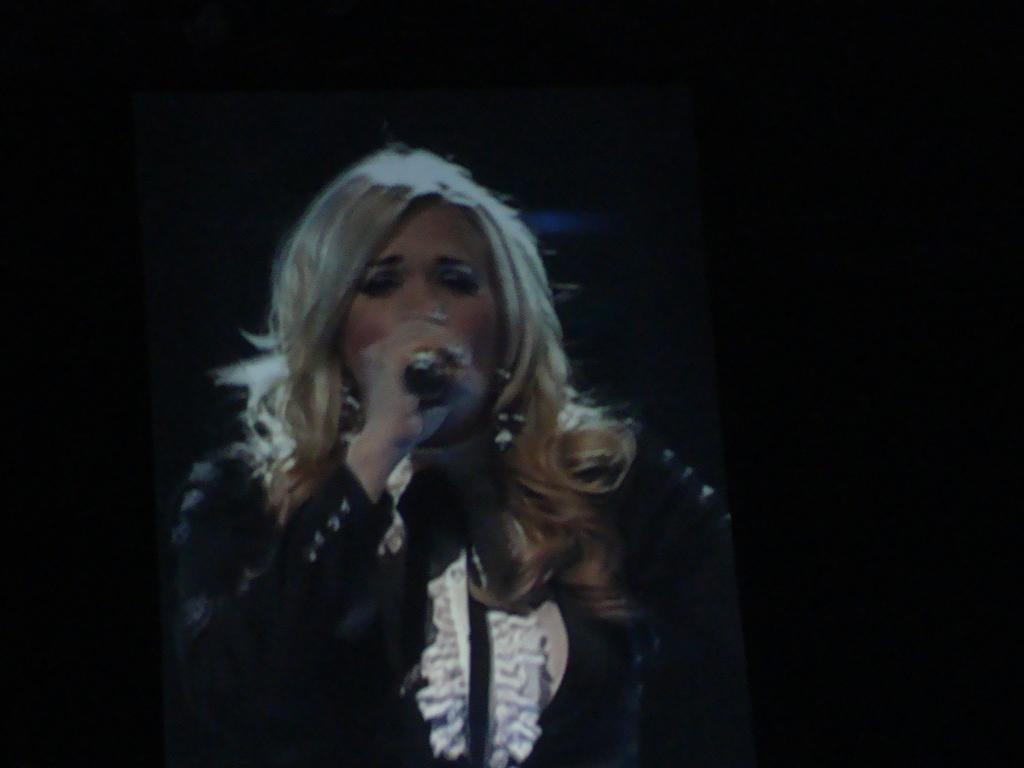Who is the main subject in the image? There is a lady in the image. What is the lady doing in the image? The lady is singing in the image. What object is the lady holding in her hand? The lady is holding a mic in her hand. What type of floor can be seen in the image? There is no information about the floor in the image, as the focus is on the lady singing and holding a mic. 